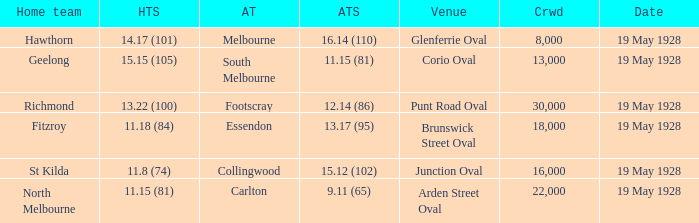What is the listed crowd when essendon is the away squad? 1.0. 